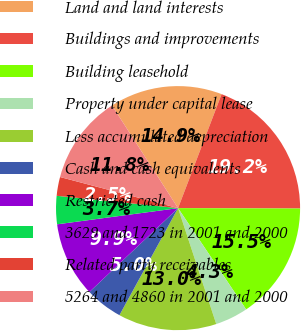Convert chart. <chart><loc_0><loc_0><loc_500><loc_500><pie_chart><fcel>Land and land interests<fcel>Buildings and improvements<fcel>Building leasehold<fcel>Property under capital lease<fcel>Less accumulated depreciation<fcel>Cash and cash equivalents<fcel>Restricted cash<fcel>3629 and 1723 in 2001 and 2000<fcel>Related party receivables<fcel>5264 and 4860 in 2001 and 2000<nl><fcel>14.91%<fcel>19.25%<fcel>15.53%<fcel>4.35%<fcel>13.04%<fcel>4.97%<fcel>9.94%<fcel>3.73%<fcel>2.49%<fcel>11.8%<nl></chart> 